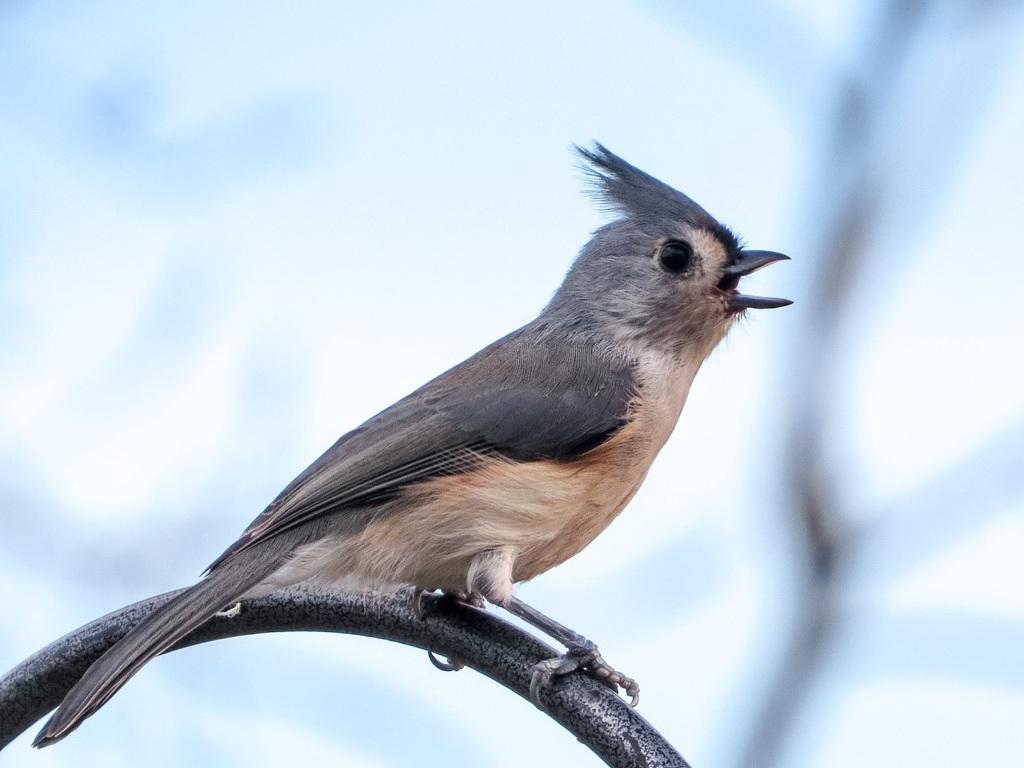Describe this image in one or two sentences. In this image in front there is a bird on the metal rod. In the background of the image there is sky. 